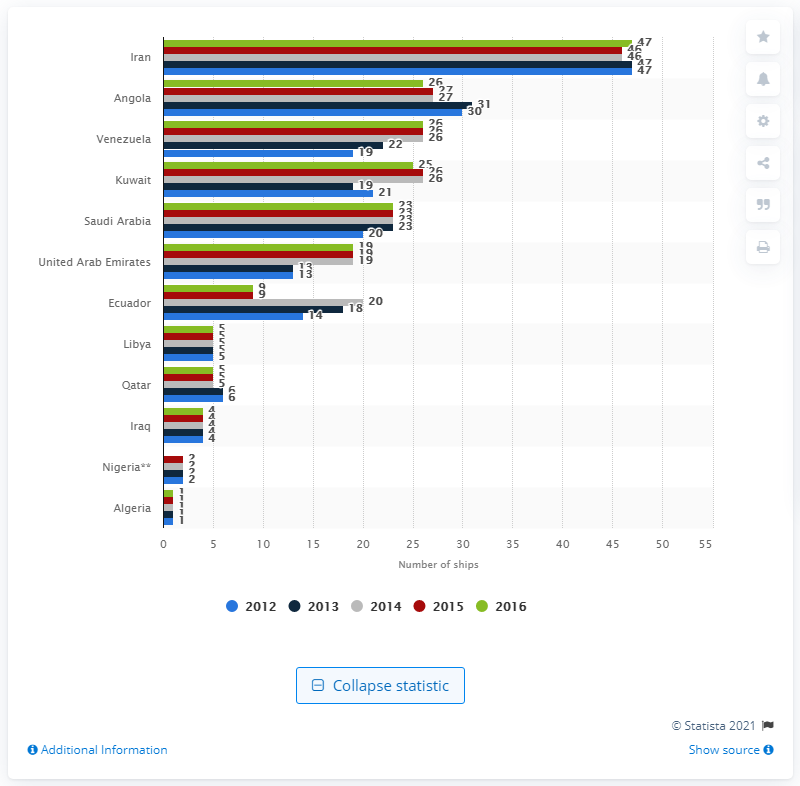Mention a couple of crucial points in this snapshot. In 2016, Saudi Arabia had a tanker fleet of 23 tanker ships. 